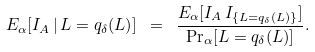<formula> <loc_0><loc_0><loc_500><loc_500>E _ { \alpha } [ I _ { A } \, | \, L = q _ { \delta } ( L ) ] \ = \ \frac { E _ { \alpha } [ I _ { A } \, I _ { \{ L = q _ { \delta } ( L ) \} } ] } { \Pr _ { \alpha } [ L = q _ { \delta } ( L ) ] } .</formula> 